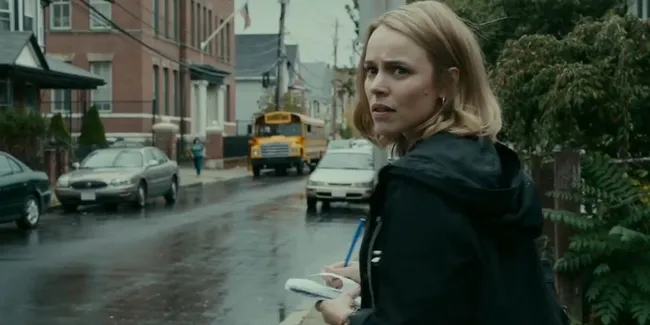Can you describe the main features of this image for me? In this image, a woman, who seems to be the actress Rachel McAdams, stands on a wet and slightly gloomy urban street. She is looking over her shoulder with a concerned expression, suggesting a moment of tension or unease. Dressed in a black jacket, she holds a white phone in one hand. The street behind her features parked cars and a yellow school bus, indicative of a typical urban neighborhood. The red-brick buildings in the background and the greenery on the right side of the image add depth and contrast to the scene, creating a visually rich environment. 